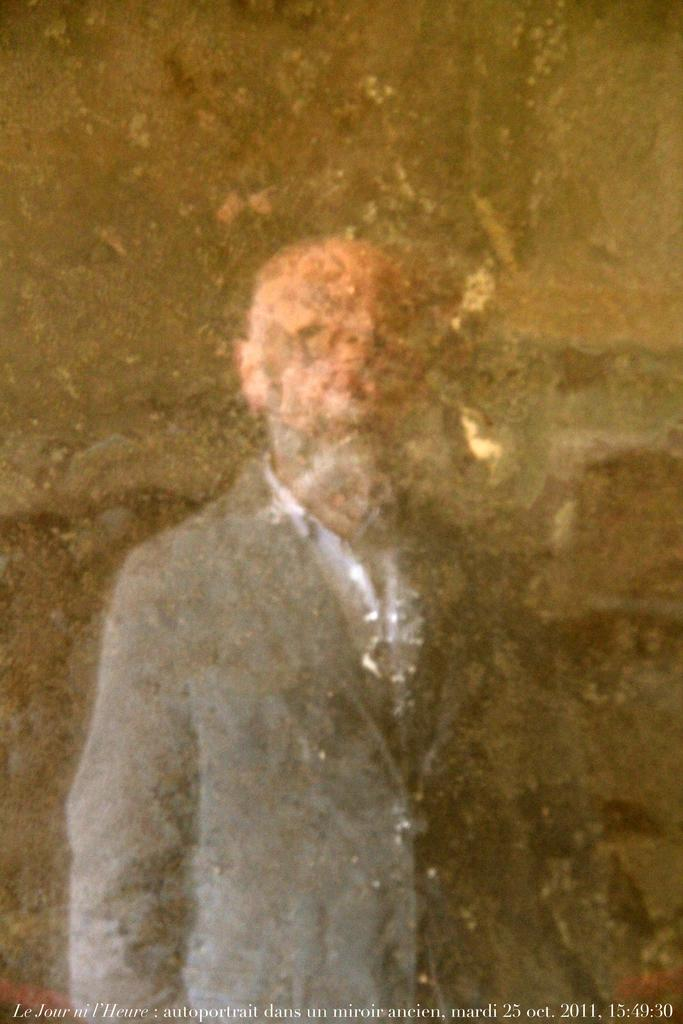What is the main subject of the image? There is a man in the image. What is the man doing in the image? The man is standing. What is the man wearing in the image? The man is wearing a suit. What type of sun can be seen on the man's hat in the image? There is no sun present on the man's hat in the image. 